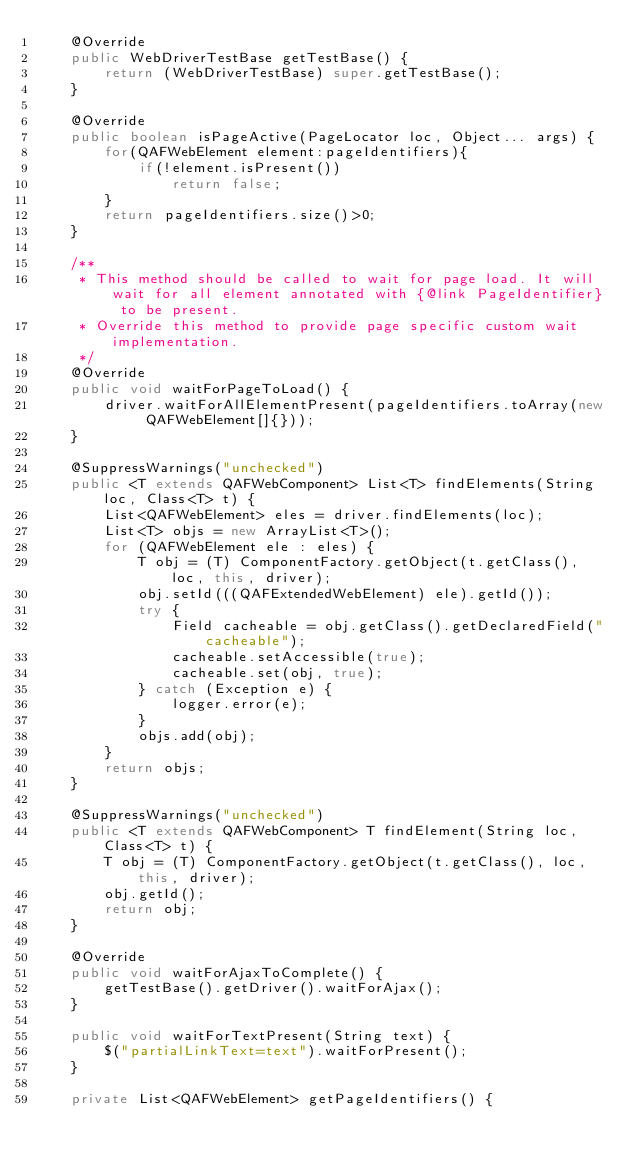Convert code to text. <code><loc_0><loc_0><loc_500><loc_500><_Java_>	@Override
	public WebDriverTestBase getTestBase() {
		return (WebDriverTestBase) super.getTestBase();
	}

	@Override
	public boolean isPageActive(PageLocator loc, Object... args) {
		for(QAFWebElement element:pageIdentifiers){
			if(!element.isPresent())
				return false;
		}
		return pageIdentifiers.size()>0;
	}
	
	/**
	 * This method should be called to wait for page load. It will wait for all element annotated with {@link PageIdentifier} to be present. 
	 * Override this method to provide page specific custom wait implementation. 
	 */
	@Override
	public void waitForPageToLoad() {
		driver.waitForAllElementPresent(pageIdentifiers.toArray(new QAFWebElement[]{}));
	}

	@SuppressWarnings("unchecked")
	public <T extends QAFWebComponent> List<T> findElements(String loc, Class<T> t) {
		List<QAFWebElement> eles = driver.findElements(loc);
		List<T> objs = new ArrayList<T>();
		for (QAFWebElement ele : eles) {
			T obj = (T) ComponentFactory.getObject(t.getClass(), loc, this, driver);
			obj.setId(((QAFExtendedWebElement) ele).getId());
			try {
				Field cacheable = obj.getClass().getDeclaredField("cacheable");
				cacheable.setAccessible(true);
				cacheable.set(obj, true);
			} catch (Exception e) {
				logger.error(e);
			}
			objs.add(obj);
		}
		return objs;
	}

	@SuppressWarnings("unchecked")
	public <T extends QAFWebComponent> T findElement(String loc, Class<T> t) {
		T obj = (T) ComponentFactory.getObject(t.getClass(), loc, this, driver);
		obj.getId();
		return obj;
	}

	@Override
	public void waitForAjaxToComplete() {
		getTestBase().getDriver().waitForAjax();
	}

	public void waitForTextPresent(String text) {
		$("partialLinkText=text").waitForPresent();
	}

	private List<QAFWebElement> getPageIdentifiers() {</code> 